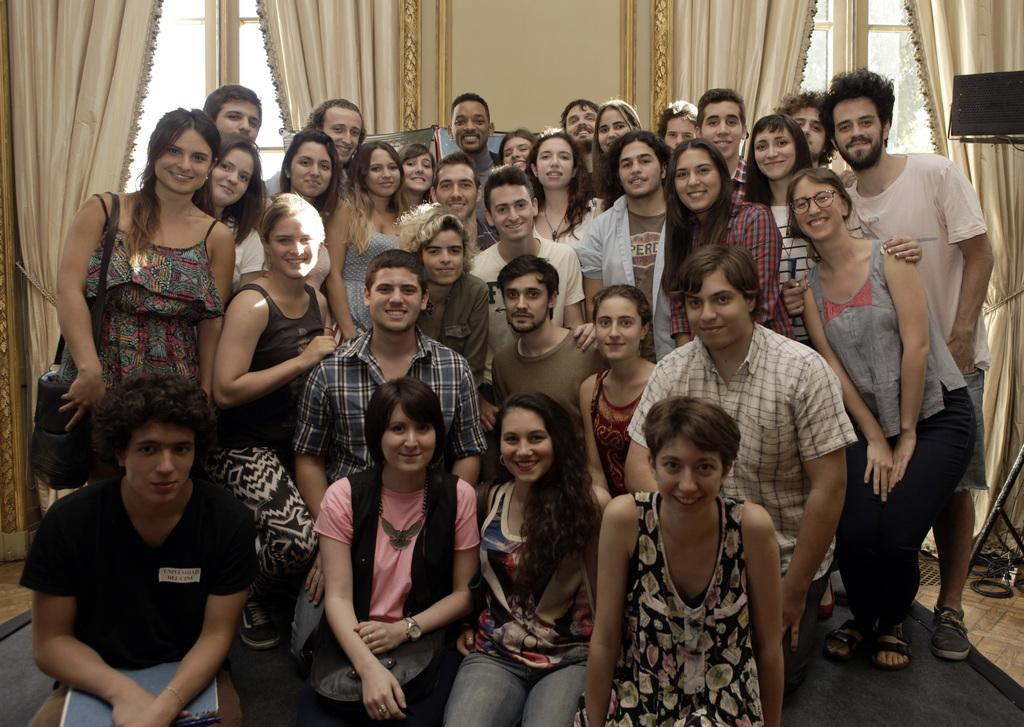What is happening in the image involving a group of people? There is a group of people in the image, and some of them are holding books and bags. What can be seen in the background of the image? There are curtains and windows in the background of the image. Can you tell me how many cacti are visible in the image? There are no cacti present in the image. What type of door can be seen in the image? There is no door visible in the image. 